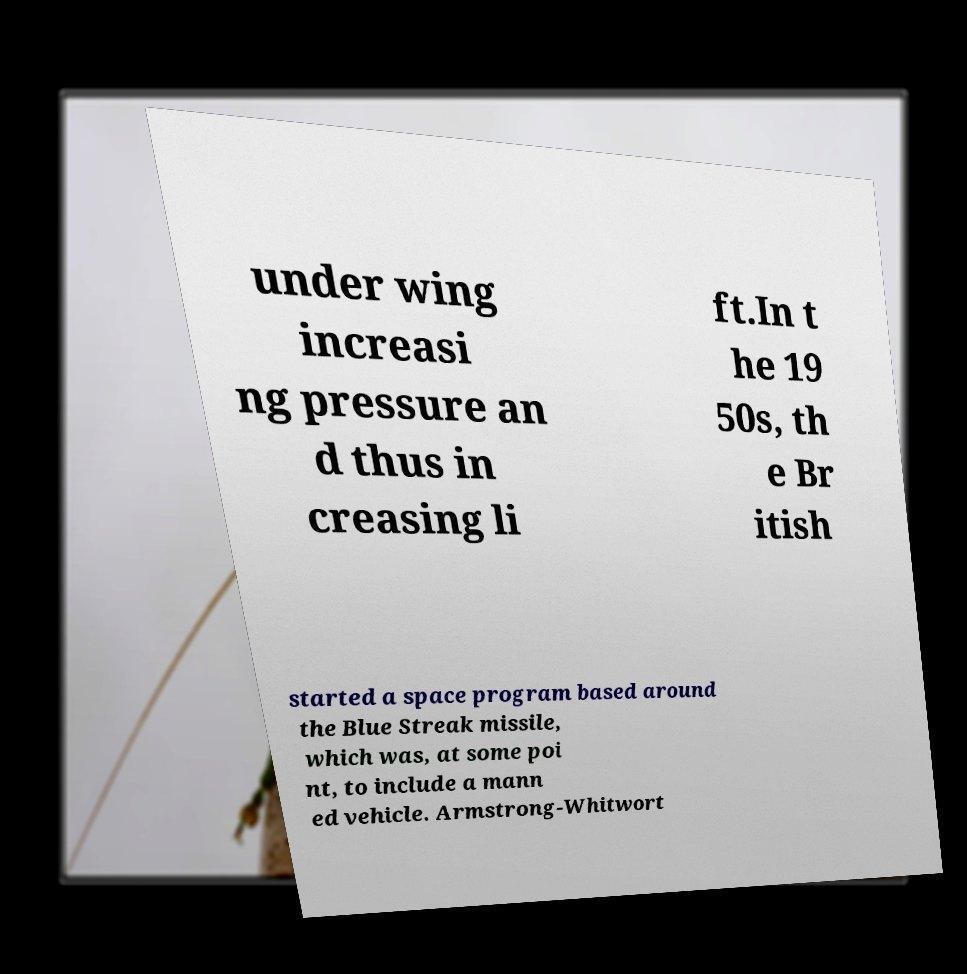Could you assist in decoding the text presented in this image and type it out clearly? under wing increasi ng pressure an d thus in creasing li ft.In t he 19 50s, th e Br itish started a space program based around the Blue Streak missile, which was, at some poi nt, to include a mann ed vehicle. Armstrong-Whitwort 